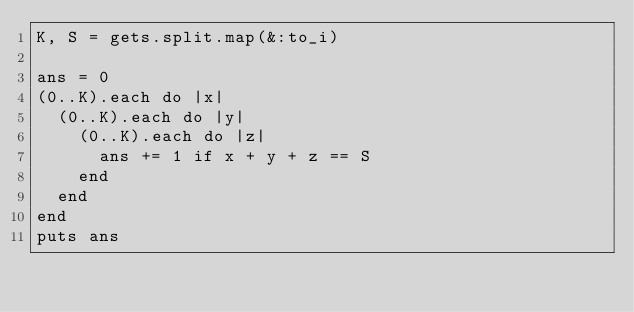<code> <loc_0><loc_0><loc_500><loc_500><_Ruby_>K, S = gets.split.map(&:to_i)

ans = 0
(0..K).each do |x|
  (0..K).each do |y|
    (0..K).each do |z|
      ans += 1 if x + y + z == S
    end
  end
end
puts ans
</code> 